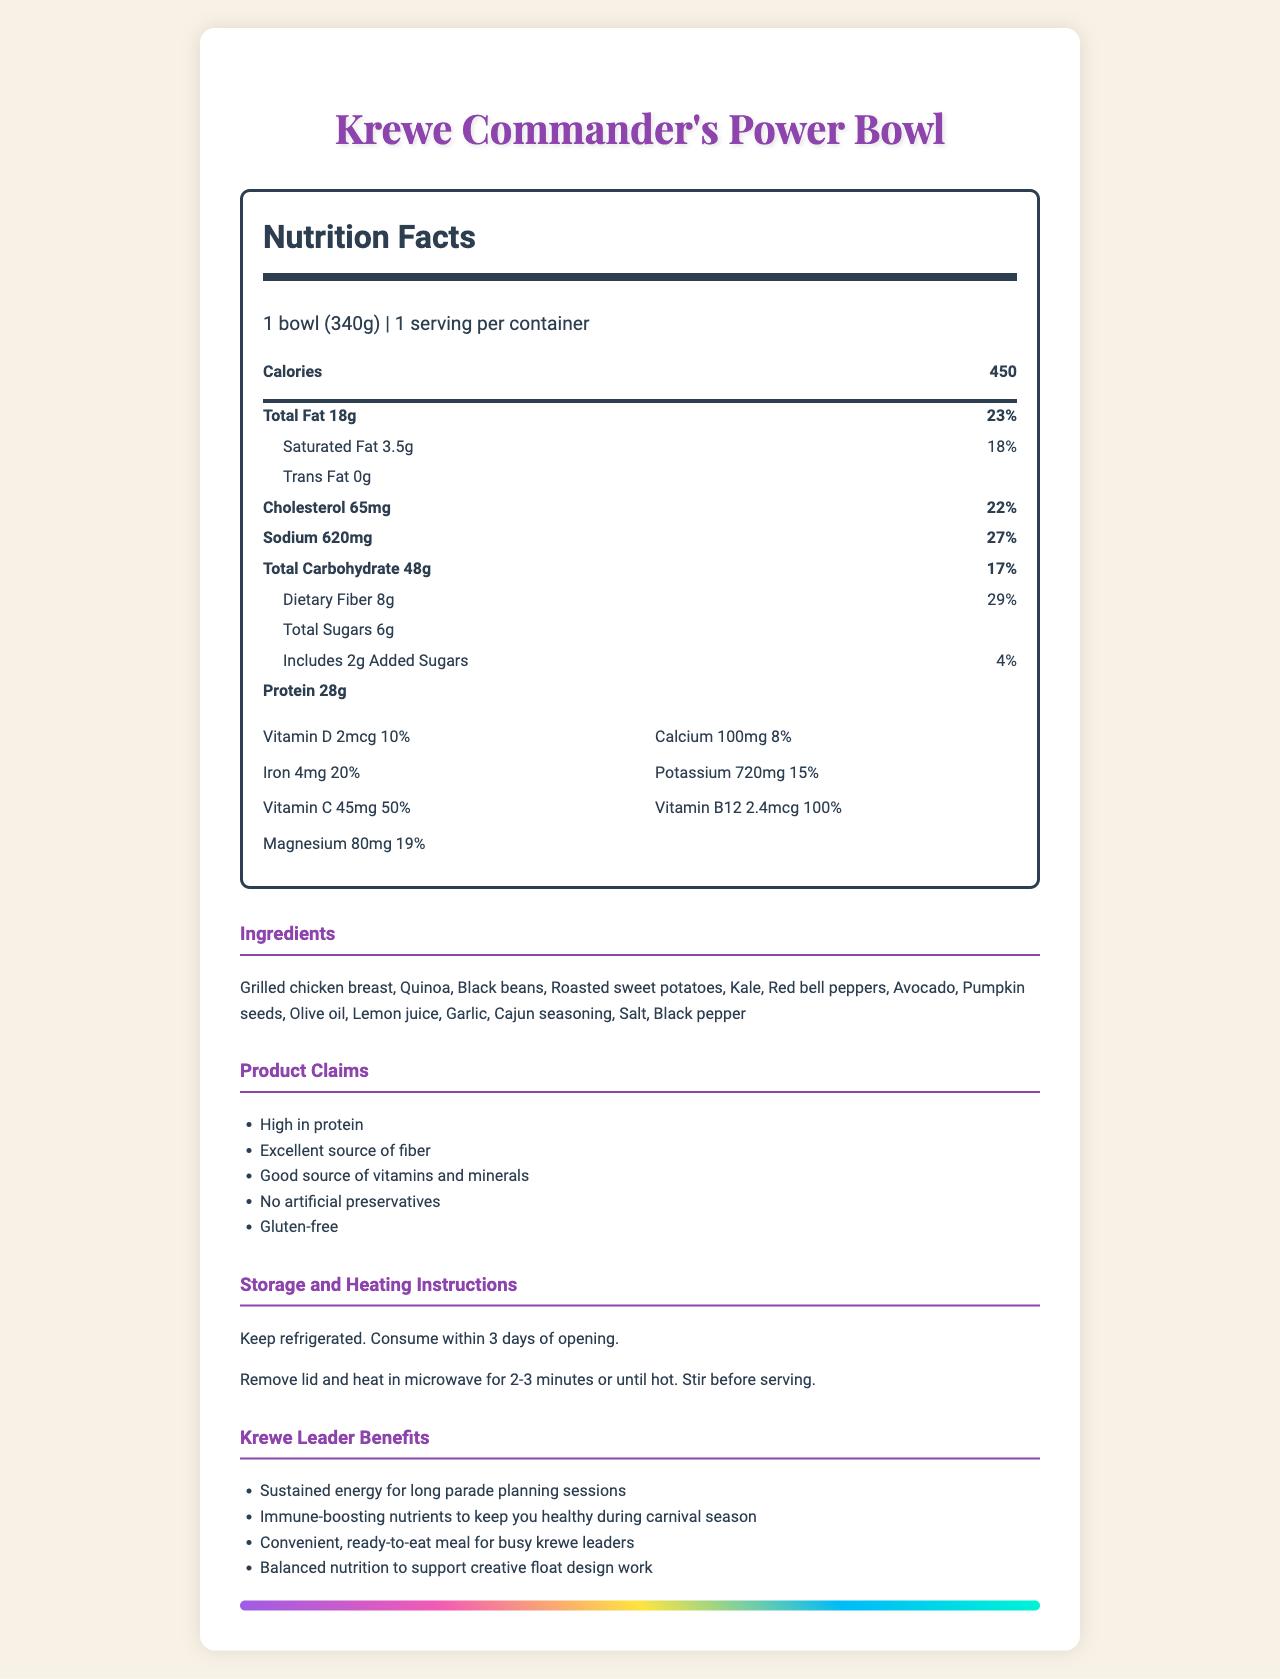what is the serving size of the Krewe Commander's Power Bowl? The serving size is specifically mentioned as "1 bowl (340g)" in the Nutrition Facts section.
Answer: 1 bowl (340g) how many grams of protein does the Power Bowl contain? The amount of protein is listed as "28g" in the Nutrition Facts section.
Answer: 28g What percentage of the daily value for dietary fiber is in the Power Bowl? The daily value percentage for dietary fiber is indicated as 29% in the Nutrition Facts section.
Answer: 29% List two of the main ingredients in the Power Bowl. The ingredients list includes "Grilled chicken breast" and "Quinoa" among other items.
Answer: Grilled chicken breast, Quinoa Are there any artificial preservatives in the Power Bowl? One of the product claims is "No artificial preservatives".
Answer: No How should the Power Bowl be stored? The storage instructions section states that the bowl should be refrigerated and consumed within 3 days of opening.
Answer: Keep refrigerated. Consume within 3 days of opening. How many calories are in a single Power Bowl? The Nutrition Facts section lists the calories as 450.
Answer: 450 What is the amount of vitamin C provided in the Power Bowl? The amount of vitamin C is listed as "45mg" in the vitamins section.
Answer: 45mg Is the Krewe Commander's Power Bowl gluten-free? One of the product claims is "Gluten-free".
Answer: Yes Which of the following nutrients is provided at 100% of the daily value?
   1. Vitamin D
   2. Iron
   3. Vitamin B12
   4. Potassium Vitamin B12 is provided at 100% of the daily value, as listed in the vitamins section.
Answer: 3 How many grams of total carbohydrates are in the Power Bowl?
   (A) 48g
   (B) 45g
   (C) 50g
   (D) 54g The Nutrition Facts section indicates the total carbohydrates as "48g".
Answer: A Did the Power Bowl contain any major allergens? The allergens section specifies "Contains: None of the major allergens".
Answer: No Does the Power Bowl provide a good source of vitamins and minerals? One of the product claims is "Good source of vitamins and minerals".
Answer: Yes Summarize the main benefits of the Krewe Commander's Power Bowl for krewe leaders. These benefits are listed under the Krewe Leader Benefits section of the document.
Answer: The Krewe Commander's Power Bowl provides sustained energy for long parade planning sessions, immune-boosting nutrients to keep leaders healthy during carnival season, convenient ready-to-eat meals for busy leaders, and balanced nutrition to support creative float design work. What kind of innovative float designs are featured in this document? The document does not provide any details about specific innovative float designs; it focuses on the nutrition facts of the Power Bowl.
Answer: Not enough information 